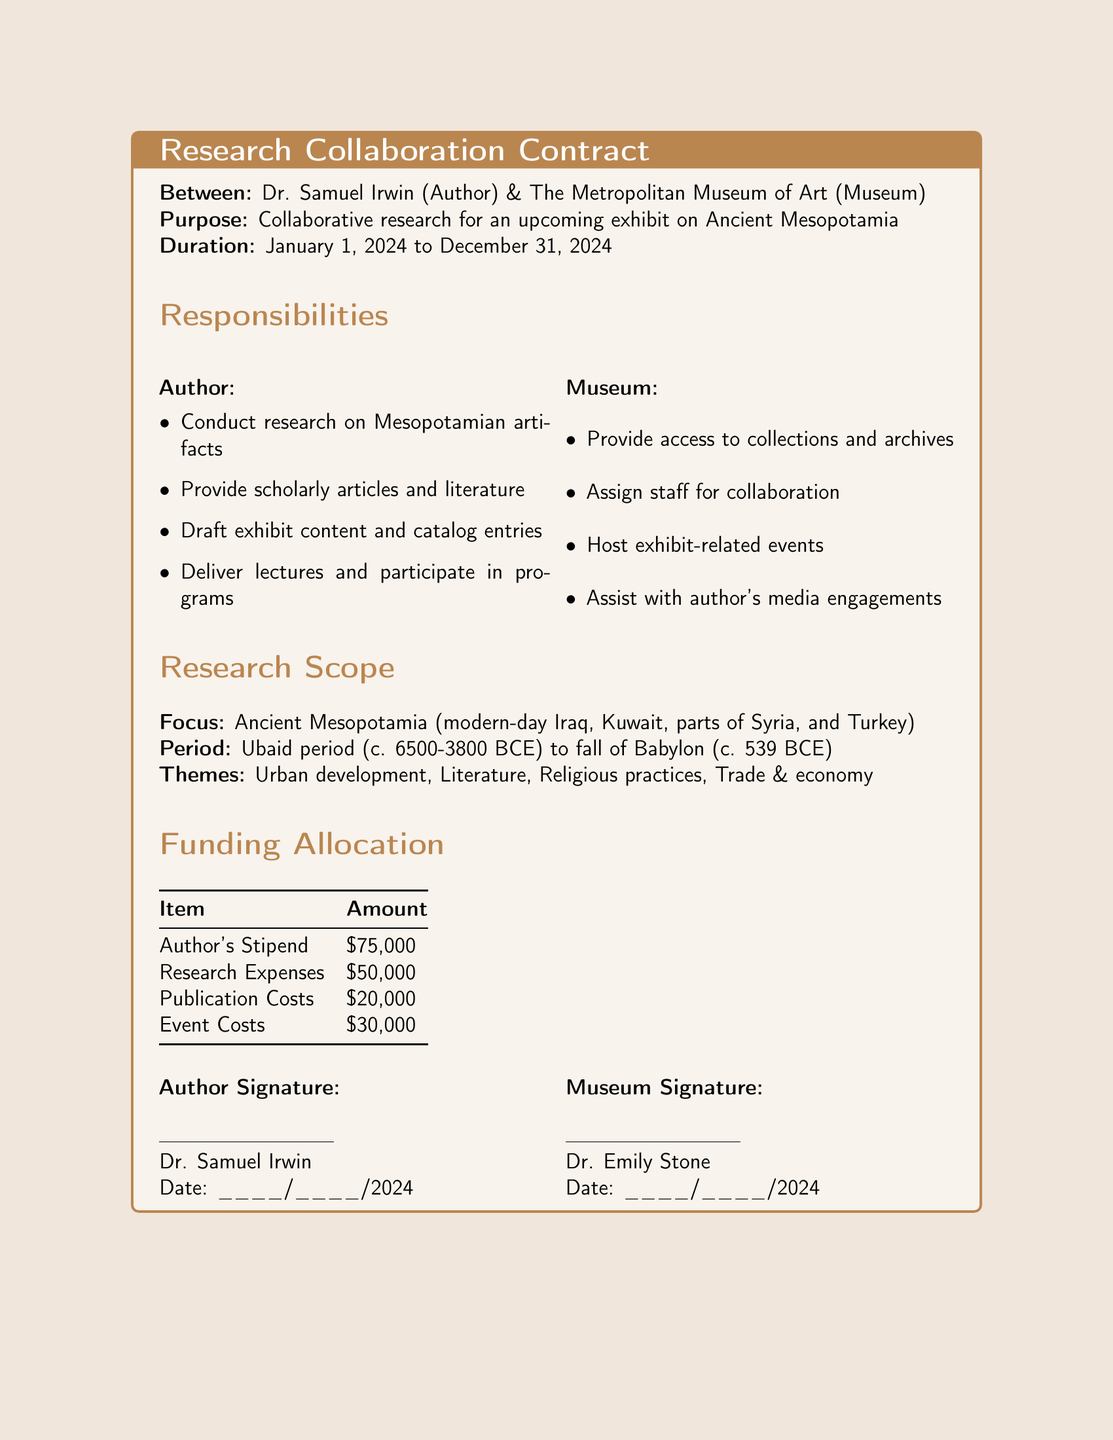What is the author's name? The author's name is mentioned at the beginning of the document as Dr. Samuel Irwin.
Answer: Dr. Samuel Irwin What is the duration of the contract? The duration of the contract is specified in the document as January 1, 2024 to December 31, 2024.
Answer: January 1, 2024 to December 31, 2024 What is the total research expenses amount? The total research expenses amount is listed in the funding allocation table, showing $50,000.
Answer: $50,000 What is one responsibility of the museum? The museum's responsibilities include providing access to collections and archives as outlined in the document.
Answer: Provide access to collections and archives What are the themes of the research scope? The themes of the research are highlighted in the research scope section, which includes Urban development, Literature, Religious practices, Trade & economy.
Answer: Urban development, Literature, Religious practices, Trade & economy Who is Dr. Emily Stone? Dr. Emily Stone is mentioned in the document as the museum's representative who signs the contract.
Answer: Museum representative What is the funding allocated for publication costs? The funding allocated for publication costs is outlined in the funding allocation table, which specifies $20,000.
Answer: $20,000 What period is the research focused on? The period of focus for the research is detailed in the document as the Ubaid period to the fall of Babylon.
Answer: Ubaid period to fall of Babylon How much is the author's stipend? The author's stipend is explicitly stated in the funding allocation section, showing it to be $75,000.
Answer: $75,000 